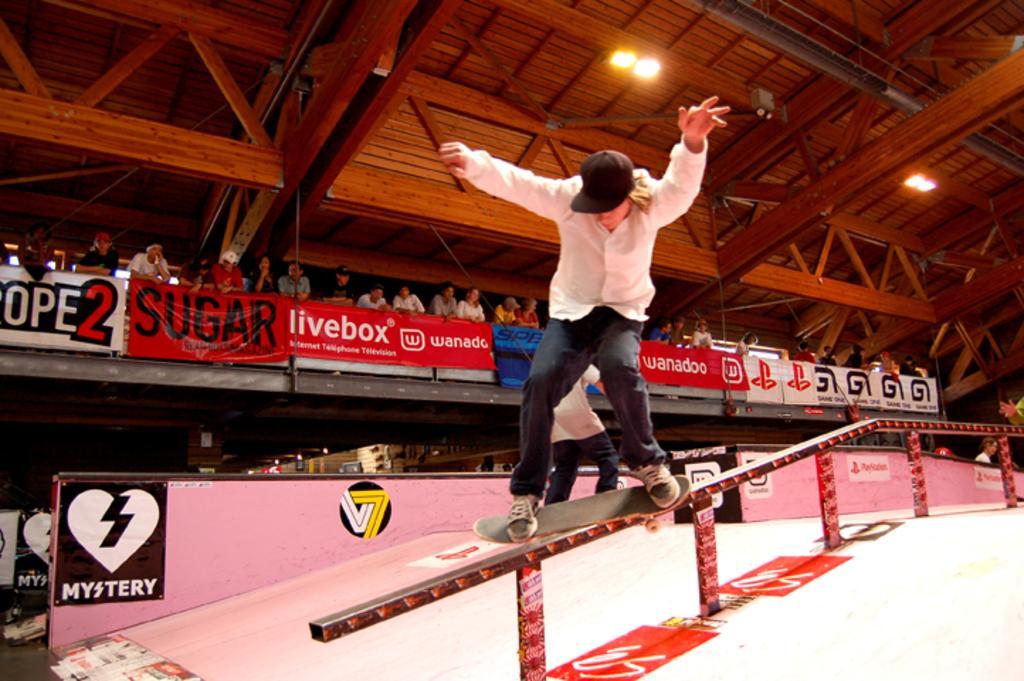How would you summarize this image in a sentence or two? In this picture I can see a man standing on the skateboard and skating on the metal rod and I can see another man in the back and few banners with some text and I can see few people standing and watching and I can see few lights on the ceiling. 